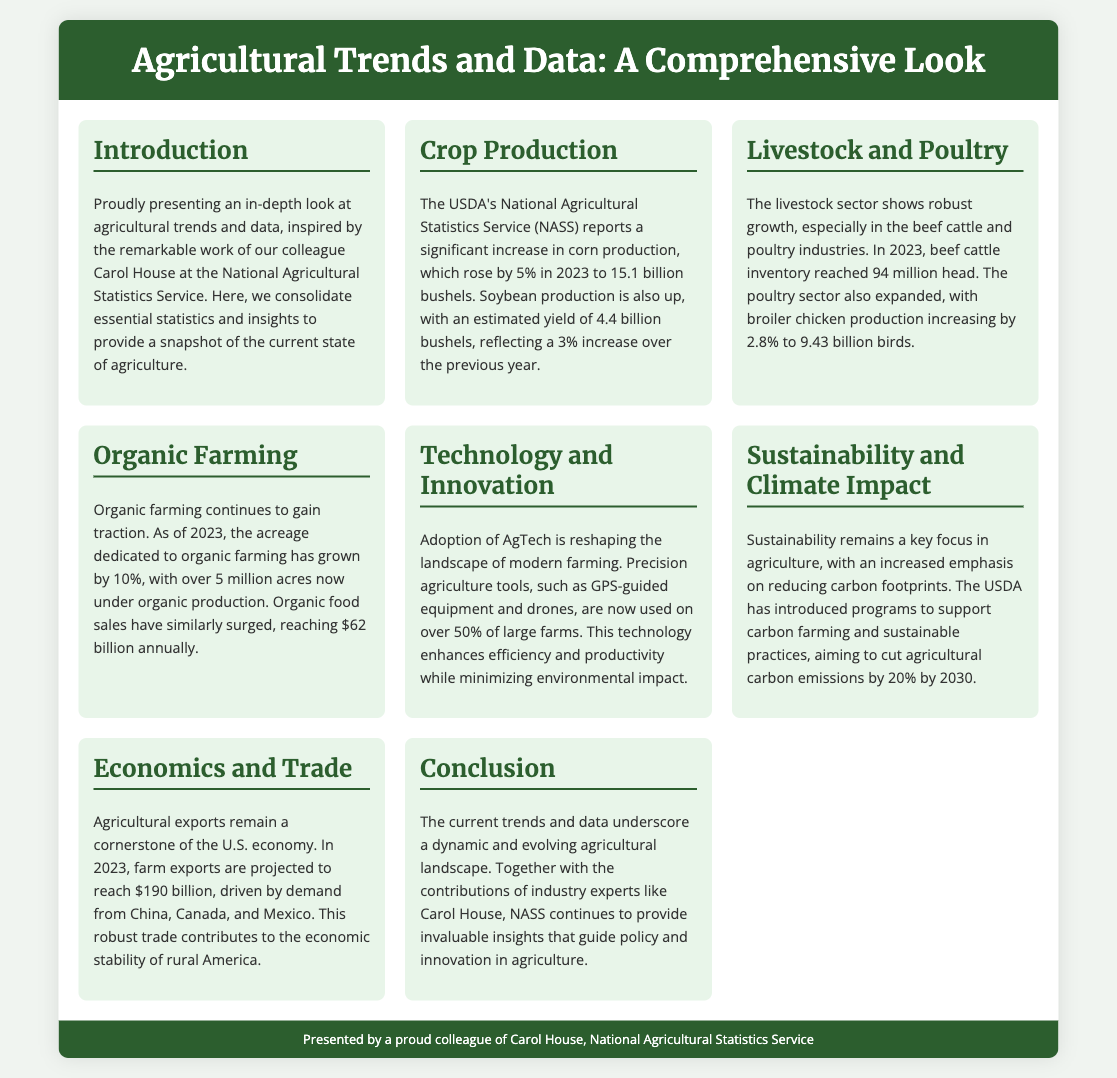What is the increase in corn production in 2023? The document states that corn production rose by 5% in 2023.
Answer: 5% What is the estimated yield of soybeans in 2023? The document provides an estimated yield of soybeans as 4.4 billion bushels for 2023.
Answer: 4.4 billion bushels How many beef cattle were reported in inventory in 2023? The inventory of beef cattle reached 94 million head in 2023, according to the document.
Answer: 94 million head What is the annual sales figure for organic food in 2023? The document mentions that organic food sales reached $62 billion annually in 2023.
Answer: $62 billion What percent of large farms use precision agriculture tools? The document indicates that over 50% of large farms utilize precision agriculture tools.
Answer: Over 50% What is the projected value of farm exports in 2023? The projected value of farm exports for 2023 is $190 billion as stated in the document.
Answer: $190 billion What is the USDA's goal for reducing agricultural carbon emissions by 2030? The document notes that the USDA aims to cut agricultural carbon emissions by 20% by 2030.
Answer: 20% Who inspired the presentation of this document? The document states that the insights were inspired by Carol House at the National Agricultural Statistics Service.
Answer: Carol House What sector shows robust growth according to the document? The document refers to robust growth in the livestock sector.
Answer: Livestock sector 